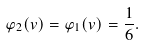Convert formula to latex. <formula><loc_0><loc_0><loc_500><loc_500>\varphi _ { 2 } ( v ) = \varphi _ { 1 } ( v ) = { \frac { 1 } { 6 } } .</formula> 